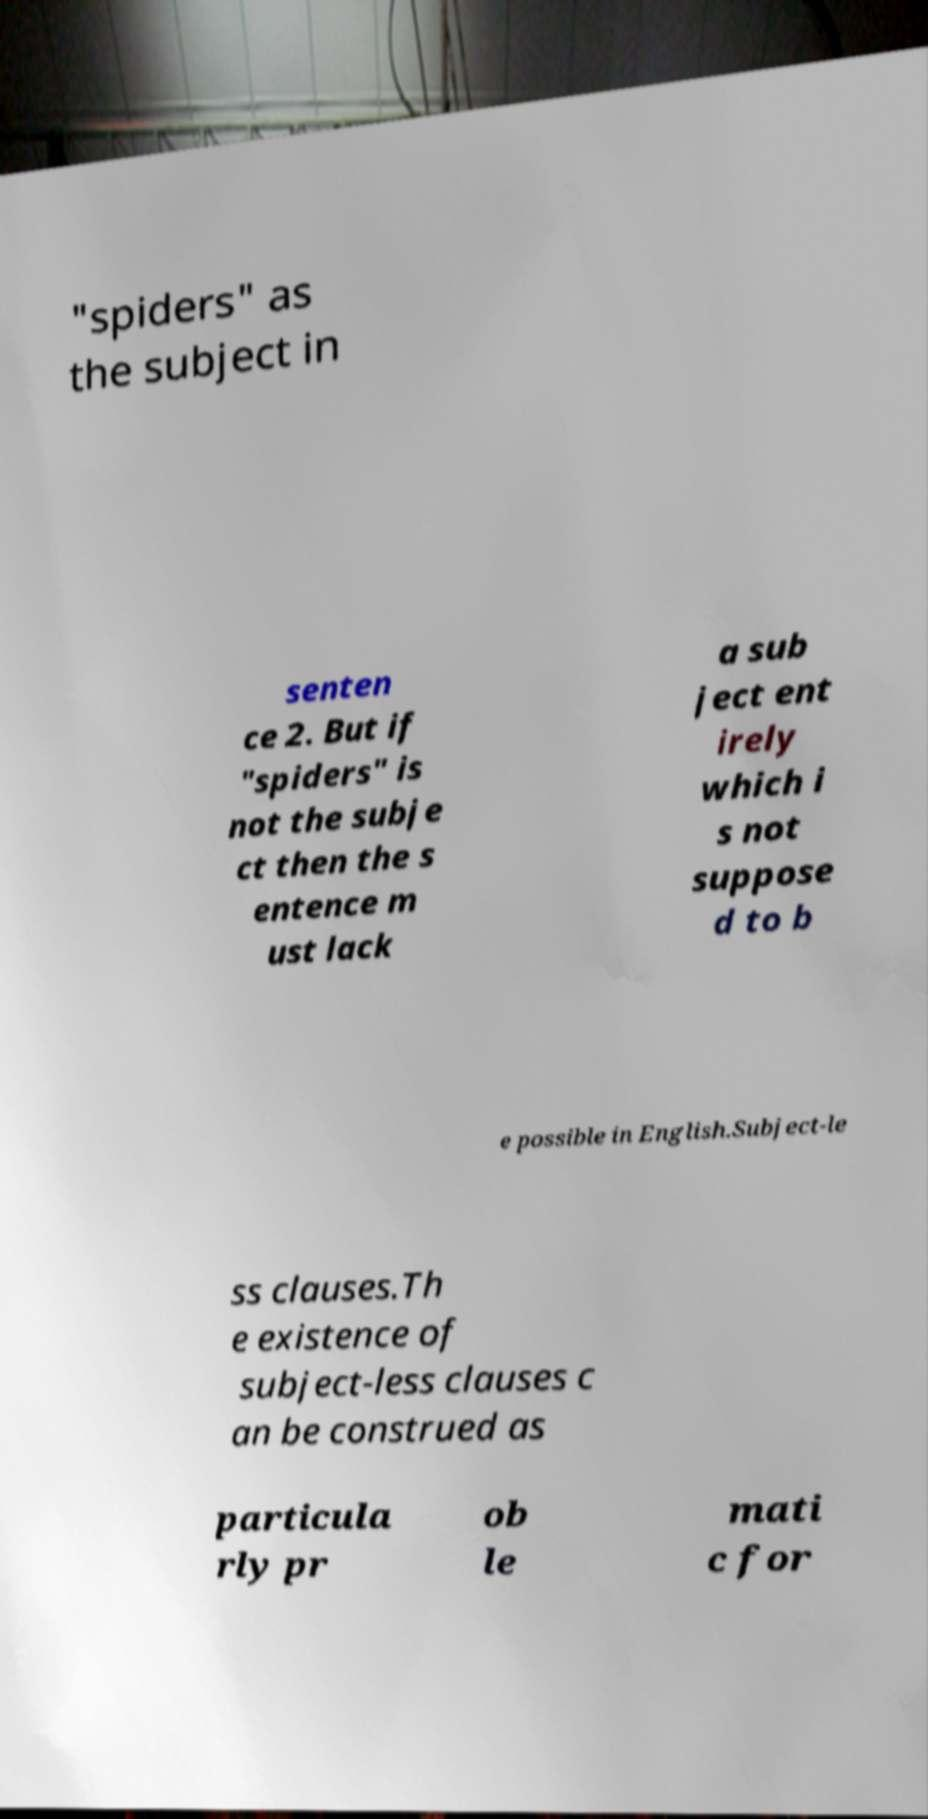Please read and relay the text visible in this image. What does it say? "spiders" as the subject in senten ce 2. But if "spiders" is not the subje ct then the s entence m ust lack a sub ject ent irely which i s not suppose d to b e possible in English.Subject-le ss clauses.Th e existence of subject-less clauses c an be construed as particula rly pr ob le mati c for 